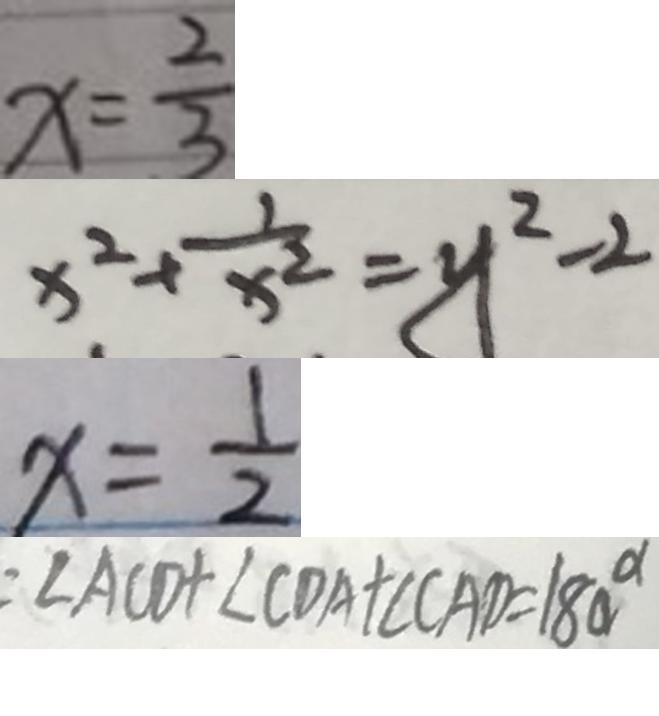Convert formula to latex. <formula><loc_0><loc_0><loc_500><loc_500>x = \frac { 2 } { 3 } 
 x ^ { 2 } + \frac { 1 } { x ^ { 2 } } = y ^ { 2 } - 2 
 x = \frac { 1 } { 2 } 
 \angle A C D + \angle C D A + \angle C A D = 1 8 0 ^ { \circ }</formula> 